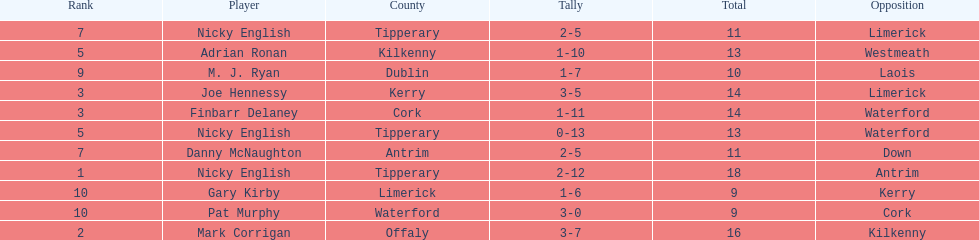If you added all the total's up, what would the number be? 138. 